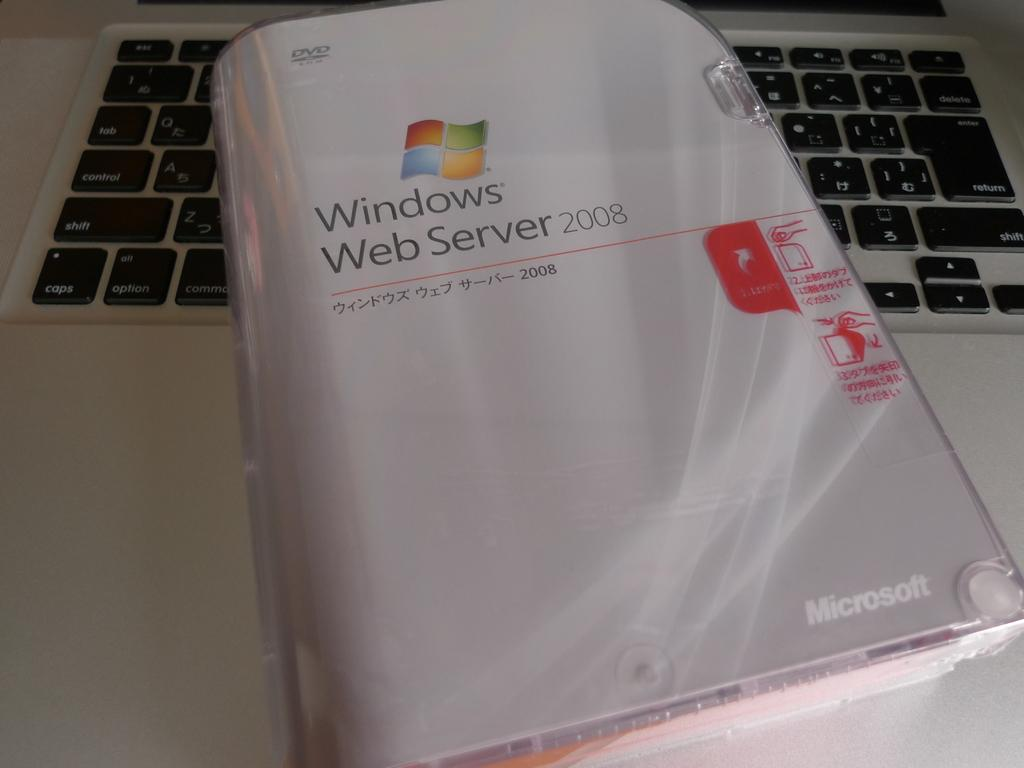<image>
Provide a brief description of the given image. A manual for Windows Web Server 2008 is wrapped in plastic. 